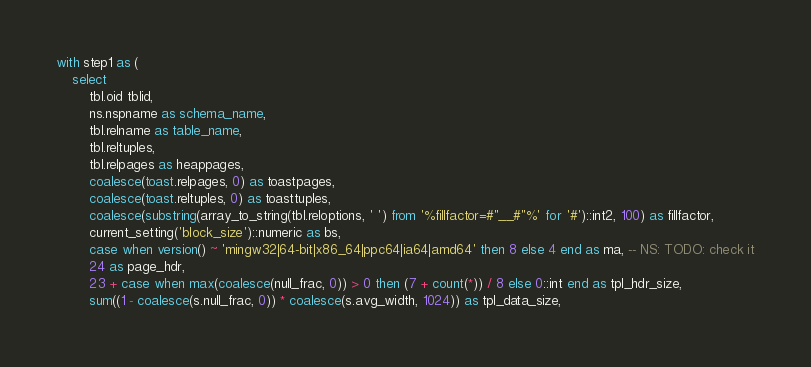Convert code to text. <code><loc_0><loc_0><loc_500><loc_500><_SQL_>with step1 as (
	select
		tbl.oid tblid,
		ns.nspname as schema_name,
		tbl.relname as table_name,
		tbl.reltuples,
		tbl.relpages as heappages,
		coalesce(toast.relpages, 0) as toastpages,
		coalesce(toast.reltuples, 0) as toasttuples,
		coalesce(substring(array_to_string(tbl.reloptions, ' ') from '%fillfactor=#"__#"%' for '#')::int2, 100) as fillfactor,
		current_setting('block_size')::numeric as bs,
		case when version() ~ 'mingw32|64-bit|x86_64|ppc64|ia64|amd64' then 8 else 4 end as ma, -- NS: TODO: check it
		24 as page_hdr,
		23 + case when max(coalesce(null_frac, 0)) > 0 then (7 + count(*)) / 8 else 0::int end as tpl_hdr_size,
		sum((1 - coalesce(s.null_frac, 0)) * coalesce(s.avg_width, 1024)) as tpl_data_size,</code> 